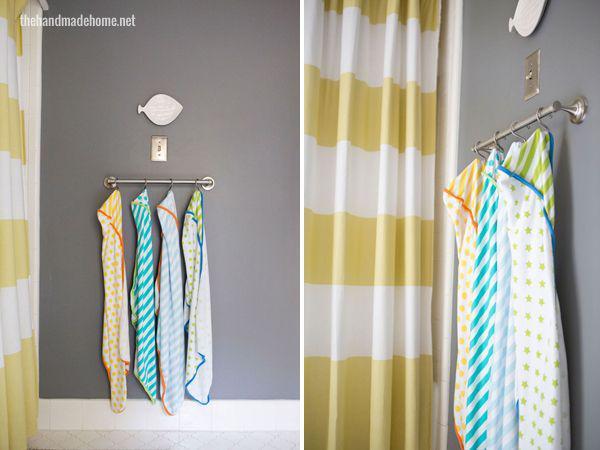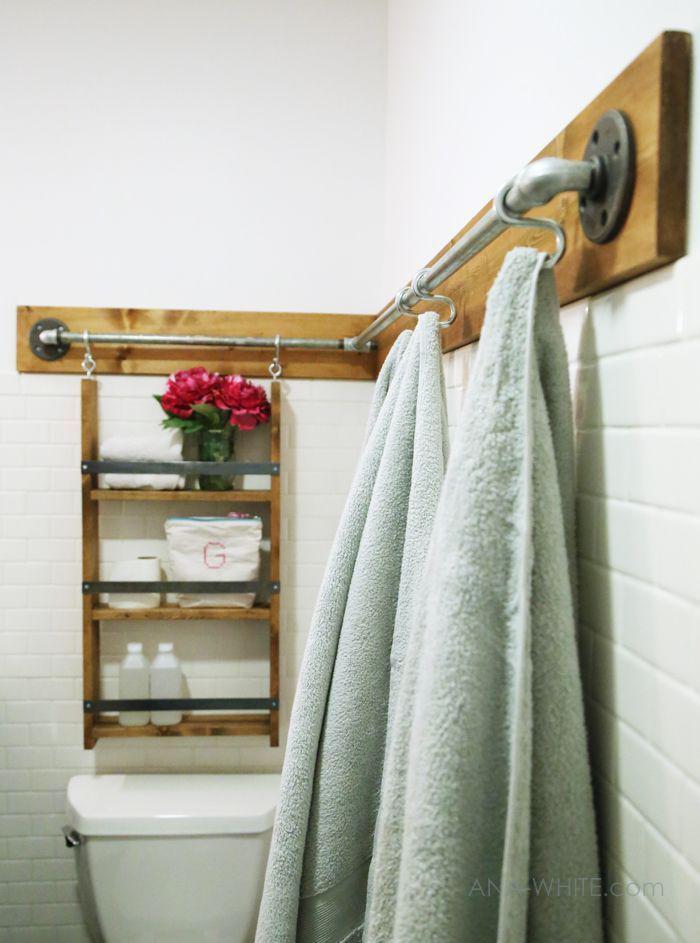The first image is the image on the left, the second image is the image on the right. Examine the images to the left and right. Is the description "In one of the images, the towels are hung on something mounted to a wooden board along the wall." accurate? Answer yes or no. Yes. 